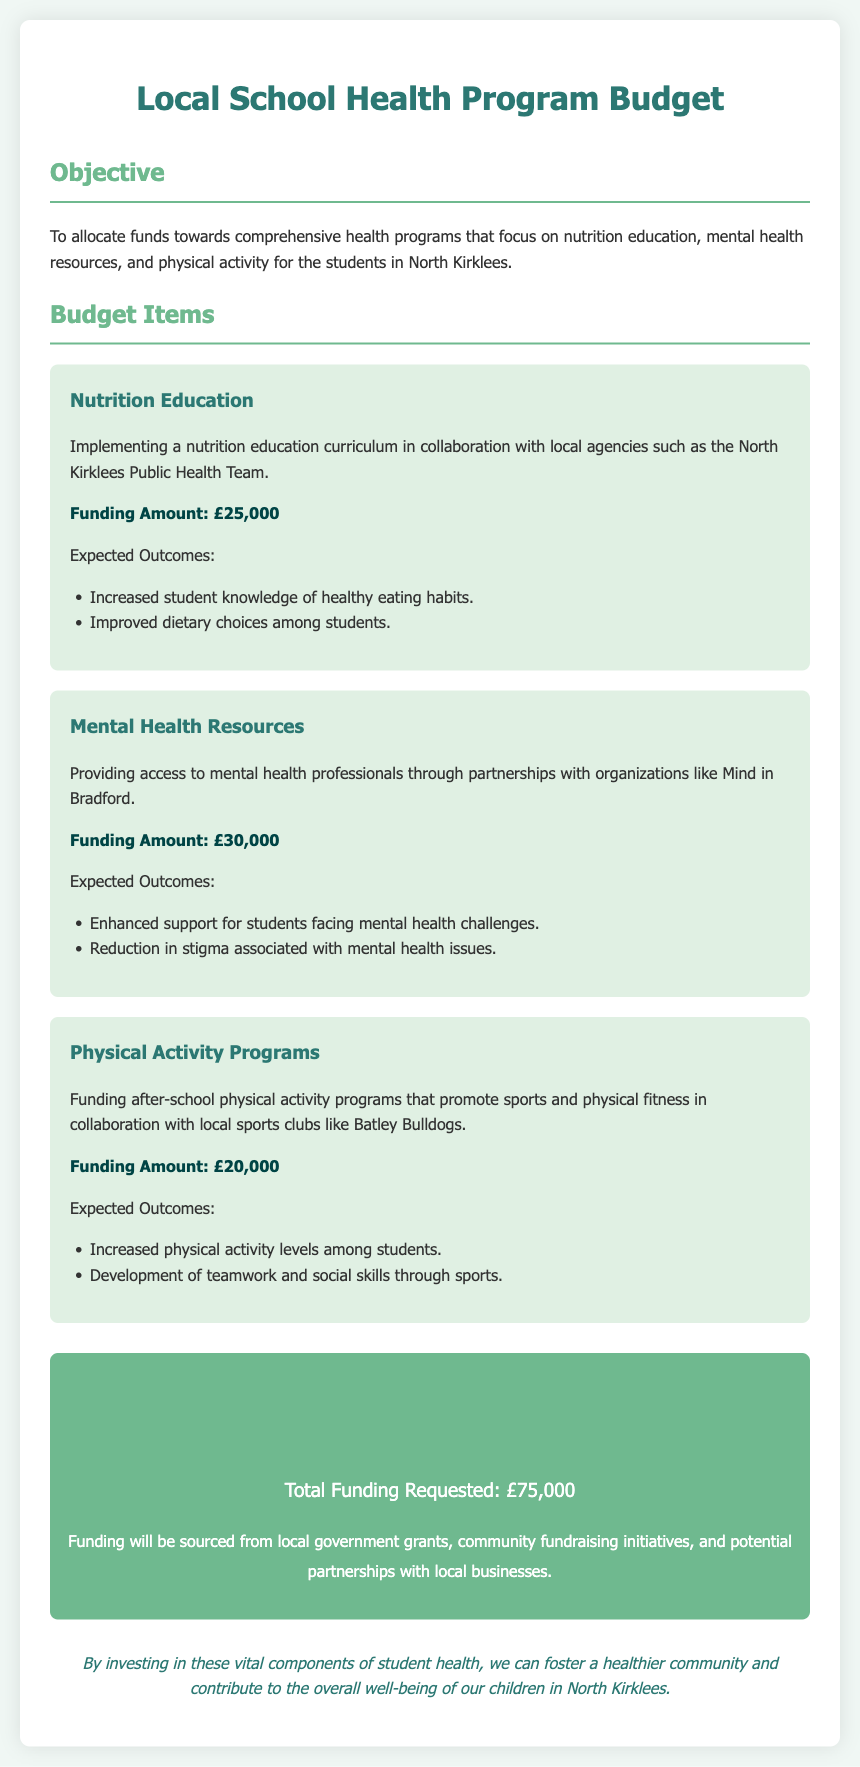What is the objective of the budget? The objective outlines the aim of the budget, which is to allocate funds towards comprehensive health programs focusing on specific areas for students.
Answer: To allocate funds towards comprehensive health programs that focus on nutrition education, mental health resources, and physical activity for the students in North Kirklees What is the funding amount for Nutrition Education? The funding amount is specified for each program in the budget document, detailing how much is allocated for the Nutrition Education initiative.
Answer: £25,000 What are the expected outcomes of the Mental Health Resources? The document lists the expected outcomes for the Mental Health Resources, indicating the anticipated benefits from the funding.
Answer: Enhanced support for students facing mental health challenges Which organization is mentioned for partnering in Mental Health Resources? The document identifies specific organizations collaborating to implement the mental health resources within the school program.
Answer: Mind in Bradford How much is allocated for Physical Activity Programs? This question refers to the specific funding allocated to the Physical Activity Programs as mentioned in the budget breakdown.
Answer: £20,000 What is the total funding requested for the Local School Health Program? The total funding is provided as a summary at the end of the document, encompassing the requests from all program areas.
Answer: £75,000 What is one expected outcome of the Nutrition Education? The expected outcomes highlight the goals of implementing the education program for student understanding and behavior regarding nutrition.
Answer: Increased student knowledge of healthy eating habits Which local sports club is mentioned in relation to Physical Activity Programs? This question seeks to identify the specific community sports club involved in the Physical Activity Programs funding initiative.
Answer: Batley Bulldogs What is the purpose of the funding sourced from local government grants? This relates to the explanation of where the funding is derived from in order to support the health program initiatives.
Answer: Funding will be sourced from local government grants, community fundraising initiatives, and potential partnerships with local businesses 